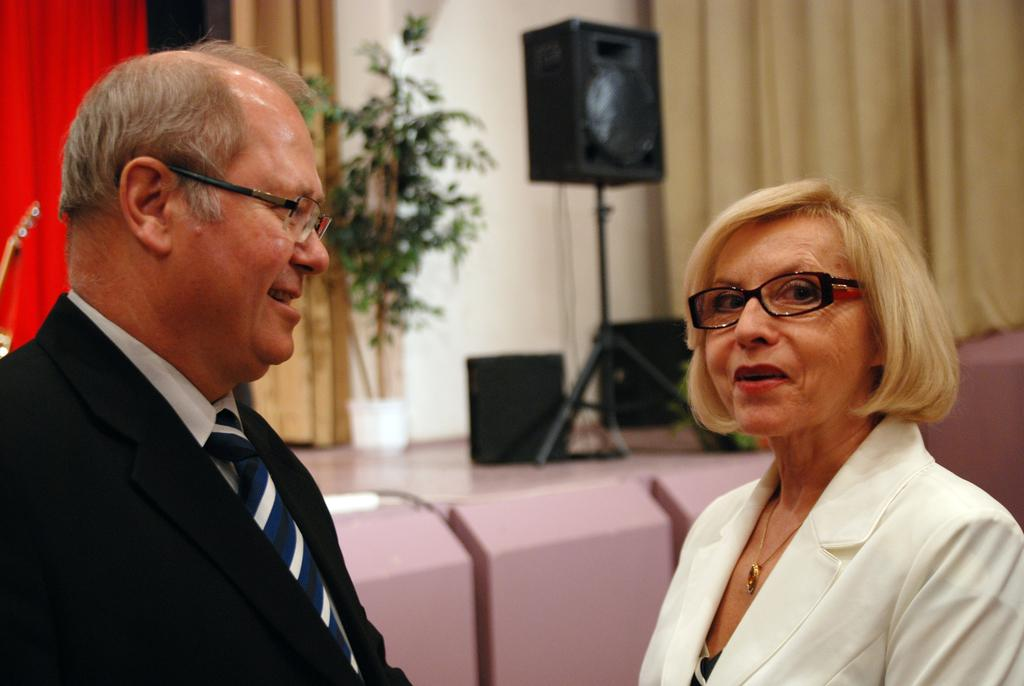How many people are in the image? There are two persons standing in the image. What is the facial expression of the persons? The persons are smiling. What objects can be seen in the image related to sound? There are speakers visible in the image. What type of vegetation is present in the image? There are plants in the image. What architectural feature is at the top of the image? There is a wall at the top of the image. What type of window treatment is associated with the wall? There are curtains associated with the wall. What type of lettuce is being used to fold the curtains in the image? There is no lettuce present in the image, and the curtains are not being folded. --- Facts: 1. There is a car in the image. 2. The car is red. 3. The car has four wheels. 4. There is a road in the image. 5. The road is paved. Absurd Topics: parrot, dance, mountain Conversation: What is the main subject of the image? The main subject of the image is a car. What color is the car? The car is red. How many wheels does the car have? The car has four wheels. What type of surface is the car on in the image? There is a road in the image, and it is paved. Reasoning: Let's think step by step in order to produce the conversation. We start by identifying the main subject of the image, which is the car. Then, we describe the car's color and the number of wheels it has. Finally, we focus on the car's surroundings, noting that it is on a paved road. Each question is designed to elicit a specific detail about the image that is known from the provided facts. Absurd Question/Answer: Can you see a parrot dancing on top of the mountain in the image? There is no parrot or mountain present in the image. 